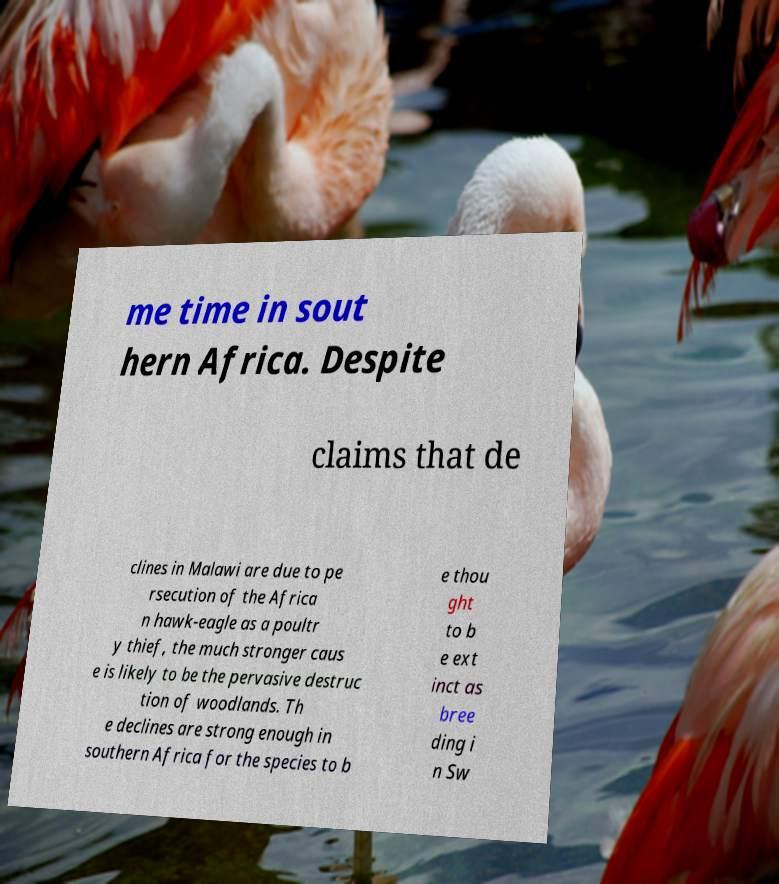Can you read and provide the text displayed in the image?This photo seems to have some interesting text. Can you extract and type it out for me? me time in sout hern Africa. Despite claims that de clines in Malawi are due to pe rsecution of the Africa n hawk-eagle as a poultr y thief, the much stronger caus e is likely to be the pervasive destruc tion of woodlands. Th e declines are strong enough in southern Africa for the species to b e thou ght to b e ext inct as bree ding i n Sw 